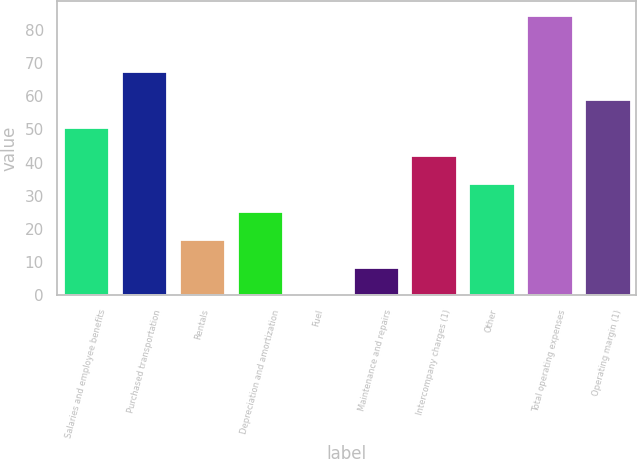<chart> <loc_0><loc_0><loc_500><loc_500><bar_chart><fcel>Salaries and employee benefits<fcel>Purchased transportation<fcel>Rentals<fcel>Depreciation and amortization<fcel>Fuel<fcel>Maintenance and repairs<fcel>Intercompany charges (1)<fcel>Other<fcel>Total operating expenses<fcel>Operating margin (1)<nl><fcel>50.68<fcel>67.54<fcel>16.96<fcel>25.39<fcel>0.1<fcel>8.53<fcel>42.25<fcel>33.82<fcel>84.4<fcel>59.11<nl></chart> 